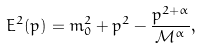Convert formula to latex. <formula><loc_0><loc_0><loc_500><loc_500>E ^ { 2 } ( p ) = m _ { 0 } ^ { 2 } + p ^ { 2 } - \frac { p ^ { 2 + \alpha } } { \mathcal { M } ^ { \alpha } } ,</formula> 